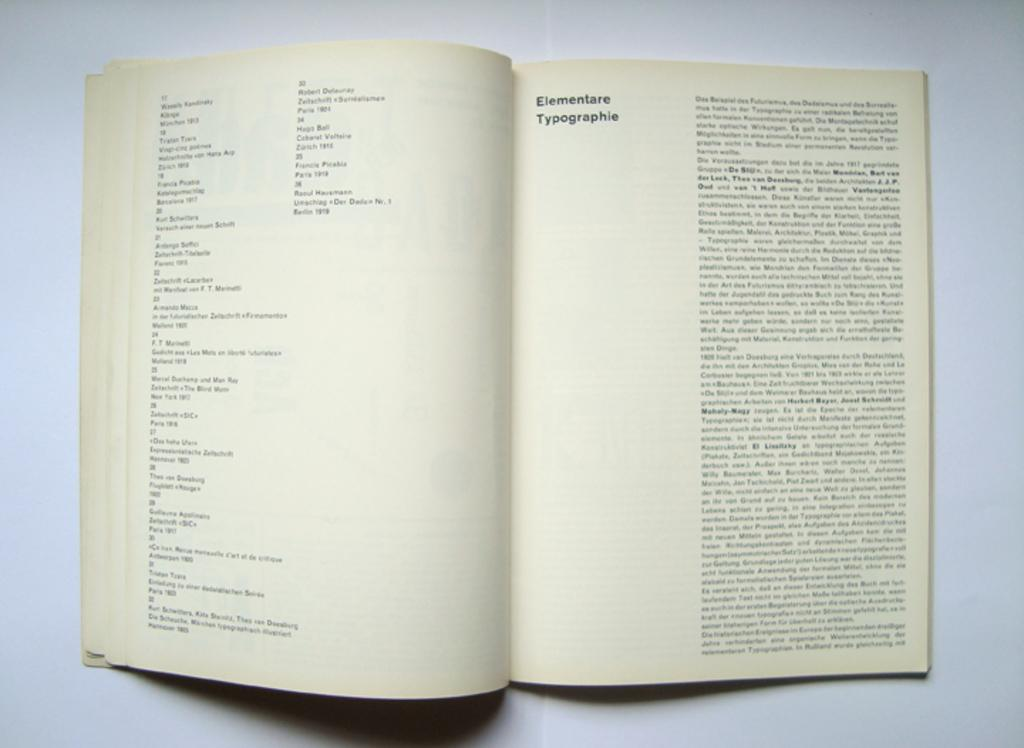<image>
Render a clear and concise summary of the photo. A book opened to a page entitled Elementare Typographie 